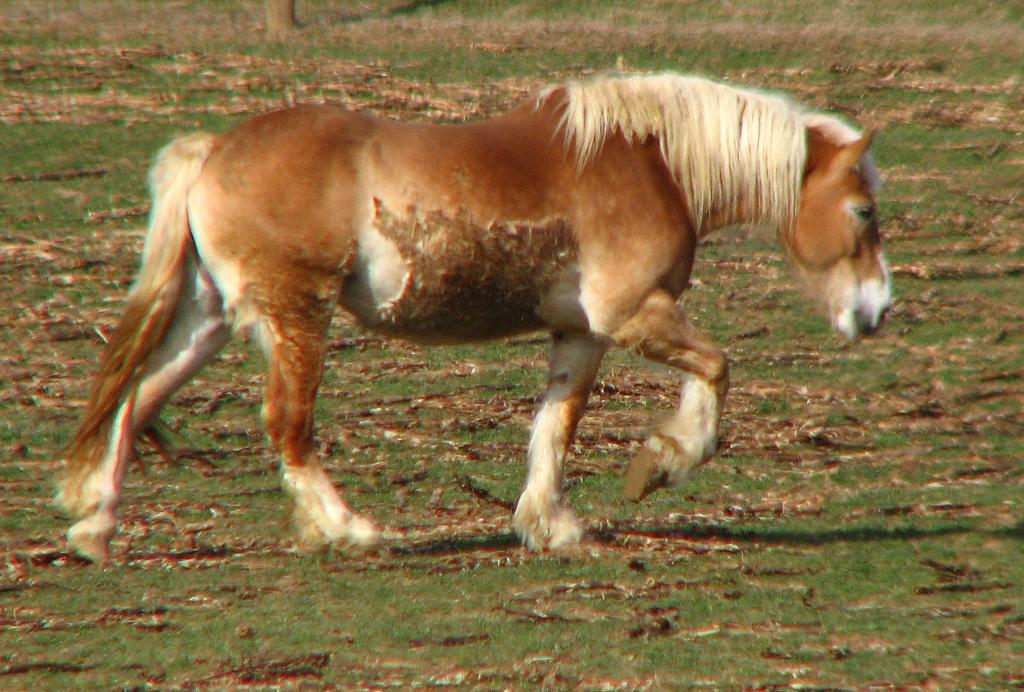What is the main subject in the middle of the image? There is a horse in the middle of the image. What type of vegetation can be seen in the image? There is grass visible in the image. What else can be found on the ground in the image? Dry leaves are present in the image. What is visible at the top of the image? The top of the image includes grass and the trunk of a tree. Where is the beggar sitting near the horse in the image? There is no beggar present in the image. What type of marble is visible on the ground in the image? There is no marble visible in the image; it features grass and dry leaves. 